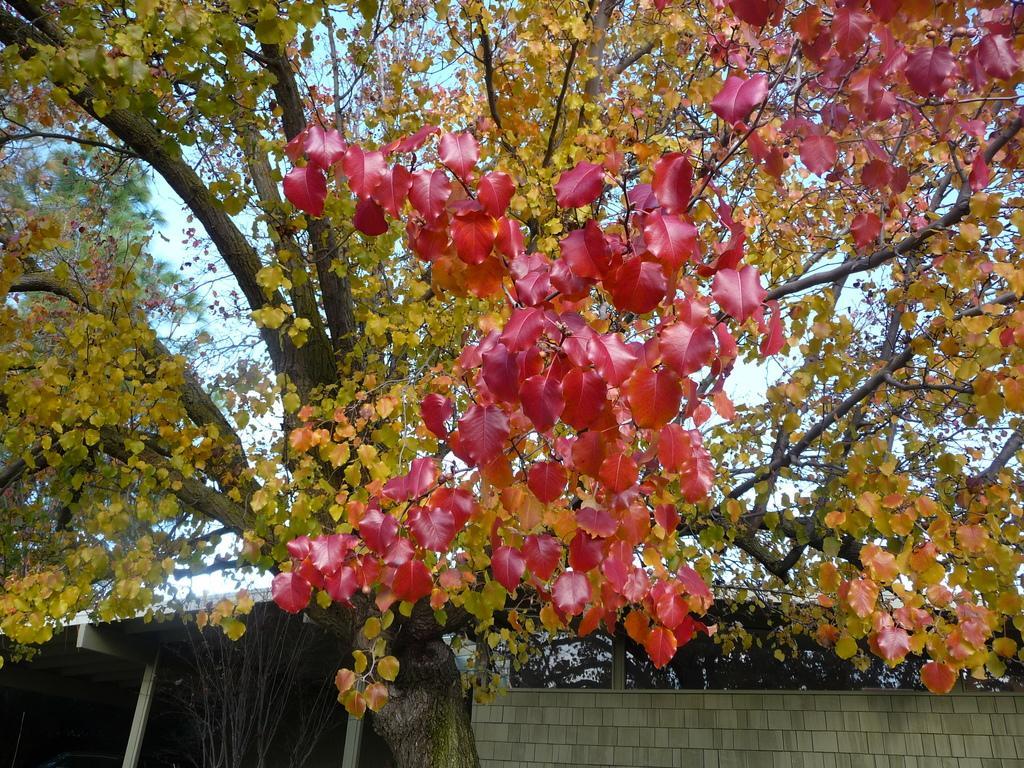In one or two sentences, can you explain what this image depicts? In this image I can see flowers in red color. Background I can see trees in green color and sky in white color. 